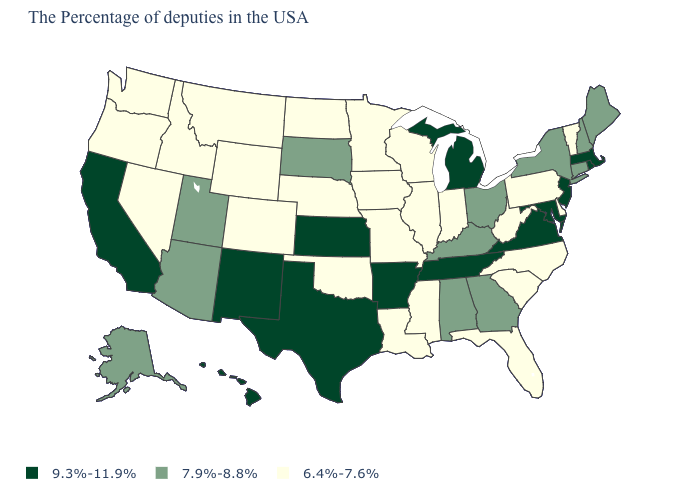What is the lowest value in the USA?
Be succinct. 6.4%-7.6%. Name the states that have a value in the range 6.4%-7.6%?
Concise answer only. Vermont, Delaware, Pennsylvania, North Carolina, South Carolina, West Virginia, Florida, Indiana, Wisconsin, Illinois, Mississippi, Louisiana, Missouri, Minnesota, Iowa, Nebraska, Oklahoma, North Dakota, Wyoming, Colorado, Montana, Idaho, Nevada, Washington, Oregon. What is the lowest value in the USA?
Write a very short answer. 6.4%-7.6%. What is the value of Vermont?
Give a very brief answer. 6.4%-7.6%. What is the value of Montana?
Keep it brief. 6.4%-7.6%. Is the legend a continuous bar?
Write a very short answer. No. Which states have the lowest value in the MidWest?
Give a very brief answer. Indiana, Wisconsin, Illinois, Missouri, Minnesota, Iowa, Nebraska, North Dakota. Does the map have missing data?
Give a very brief answer. No. Does Kentucky have the highest value in the South?
Give a very brief answer. No. What is the highest value in the USA?
Keep it brief. 9.3%-11.9%. Does North Carolina have the same value as Illinois?
Write a very short answer. Yes. Name the states that have a value in the range 6.4%-7.6%?
Keep it brief. Vermont, Delaware, Pennsylvania, North Carolina, South Carolina, West Virginia, Florida, Indiana, Wisconsin, Illinois, Mississippi, Louisiana, Missouri, Minnesota, Iowa, Nebraska, Oklahoma, North Dakota, Wyoming, Colorado, Montana, Idaho, Nevada, Washington, Oregon. Name the states that have a value in the range 9.3%-11.9%?
Concise answer only. Massachusetts, Rhode Island, New Jersey, Maryland, Virginia, Michigan, Tennessee, Arkansas, Kansas, Texas, New Mexico, California, Hawaii. Does the map have missing data?
Quick response, please. No. What is the highest value in states that border Illinois?
Keep it brief. 7.9%-8.8%. 